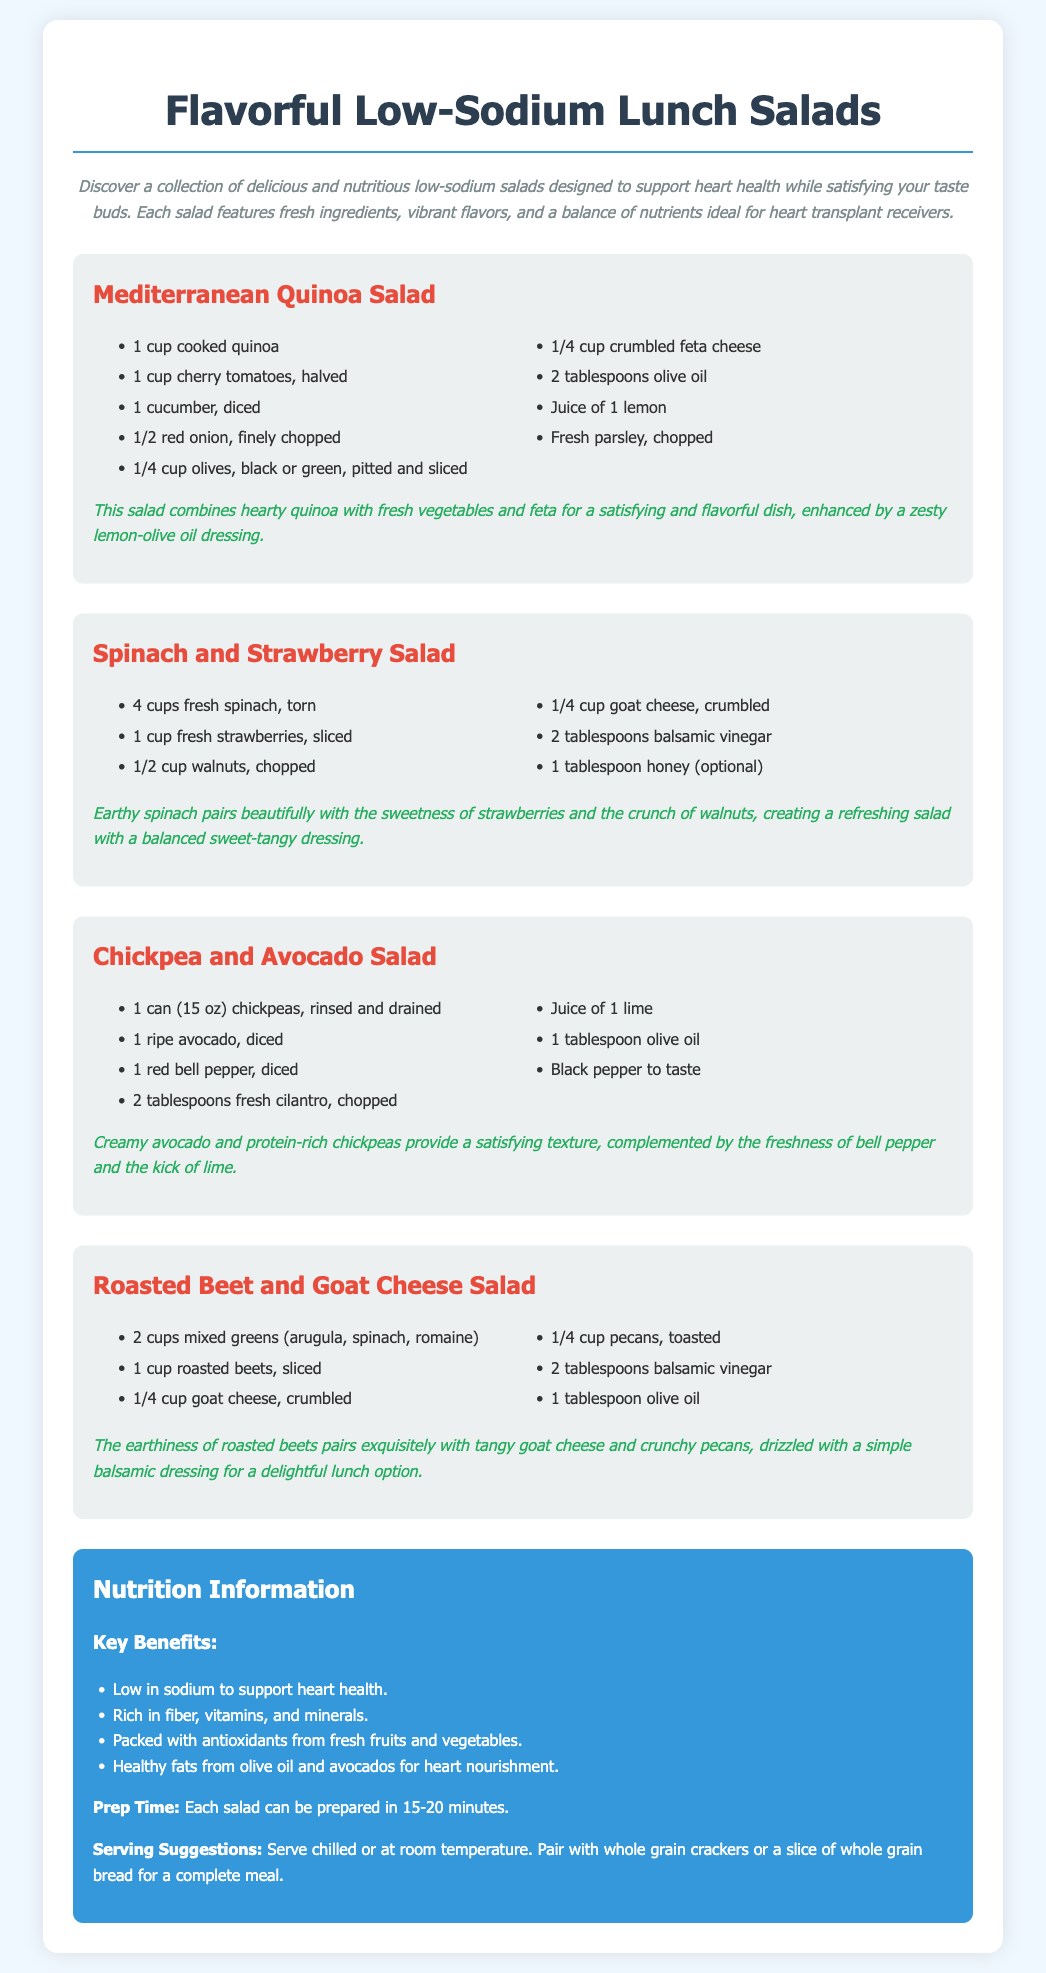What is the title of the document? The title is located in the head section of the HTML document.
Answer: Flavorful Low-Sodium Lunch Salads How many ingredients are listed for the Mediterranean Quinoa Salad? The number of ingredients is counted in the ingredients list under the Mediterranean Quinoa Salad section.
Answer: 9 Which cheese is used in the Spinach and Strawberry Salad? This information can be found in the ingredients list for the Spinach and Strawberry Salad.
Answer: Goat cheese What is the primary ingredient in the Chickpea and Avocado Salad? The primary ingredient is identified in the ingredients list of the Chickpea and Avocado Salad.
Answer: Chickpeas How long does it take to prepare each salad? This detail is found in the nutrition information section, specifically related to prep time.
Answer: 15-20 minutes What is a suggested pairing for the salads? This suggestion is provided in the serving suggestions section of the nutrition information.
Answer: Whole grain crackers Which salad includes roasted beets? The salad containing roasted beets can be found by reading the names of the salads mentioned in the document.
Answer: Roasted Beet and Goat Cheese Salad What type of vinegar is used in the Spinach and Strawberry Salad? This specific detail can be determined from the ingredients list for that salad.
Answer: Balsamic vinegar 